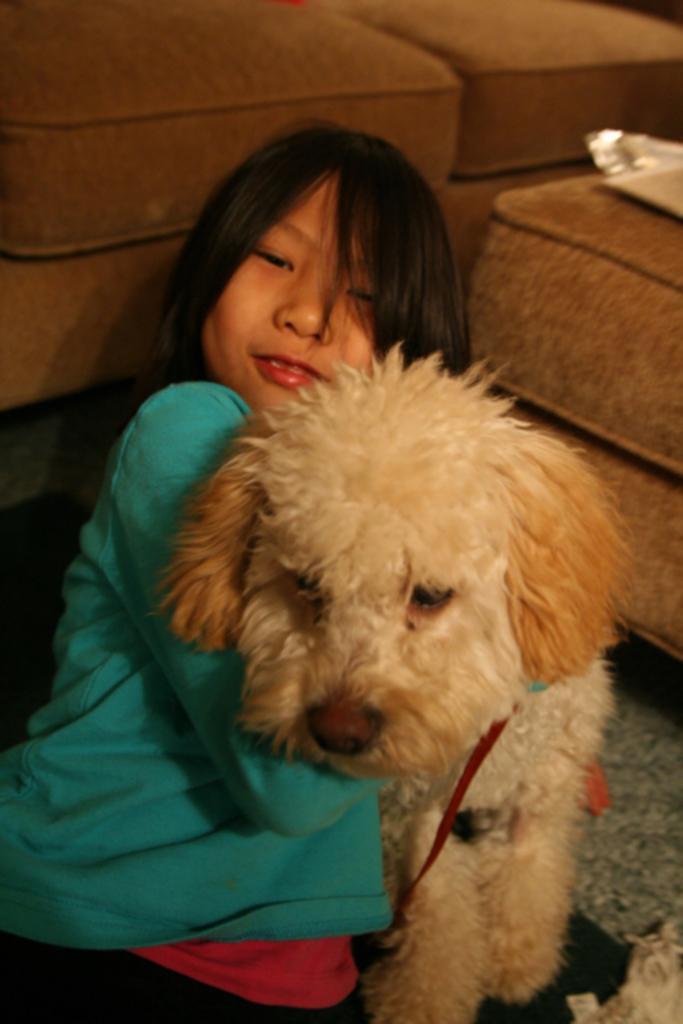Could you give a brief overview of what you see in this image? This image consists of sofas in the top and in the middle there is a kid who is holding a dog. That kid wore blue color shirt and red color pant. There is something on the Sofa on the right side. 